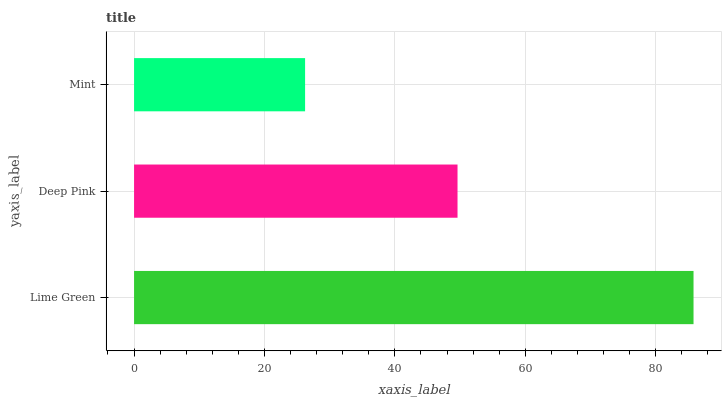Is Mint the minimum?
Answer yes or no. Yes. Is Lime Green the maximum?
Answer yes or no. Yes. Is Deep Pink the minimum?
Answer yes or no. No. Is Deep Pink the maximum?
Answer yes or no. No. Is Lime Green greater than Deep Pink?
Answer yes or no. Yes. Is Deep Pink less than Lime Green?
Answer yes or no. Yes. Is Deep Pink greater than Lime Green?
Answer yes or no. No. Is Lime Green less than Deep Pink?
Answer yes or no. No. Is Deep Pink the high median?
Answer yes or no. Yes. Is Deep Pink the low median?
Answer yes or no. Yes. Is Lime Green the high median?
Answer yes or no. No. Is Lime Green the low median?
Answer yes or no. No. 